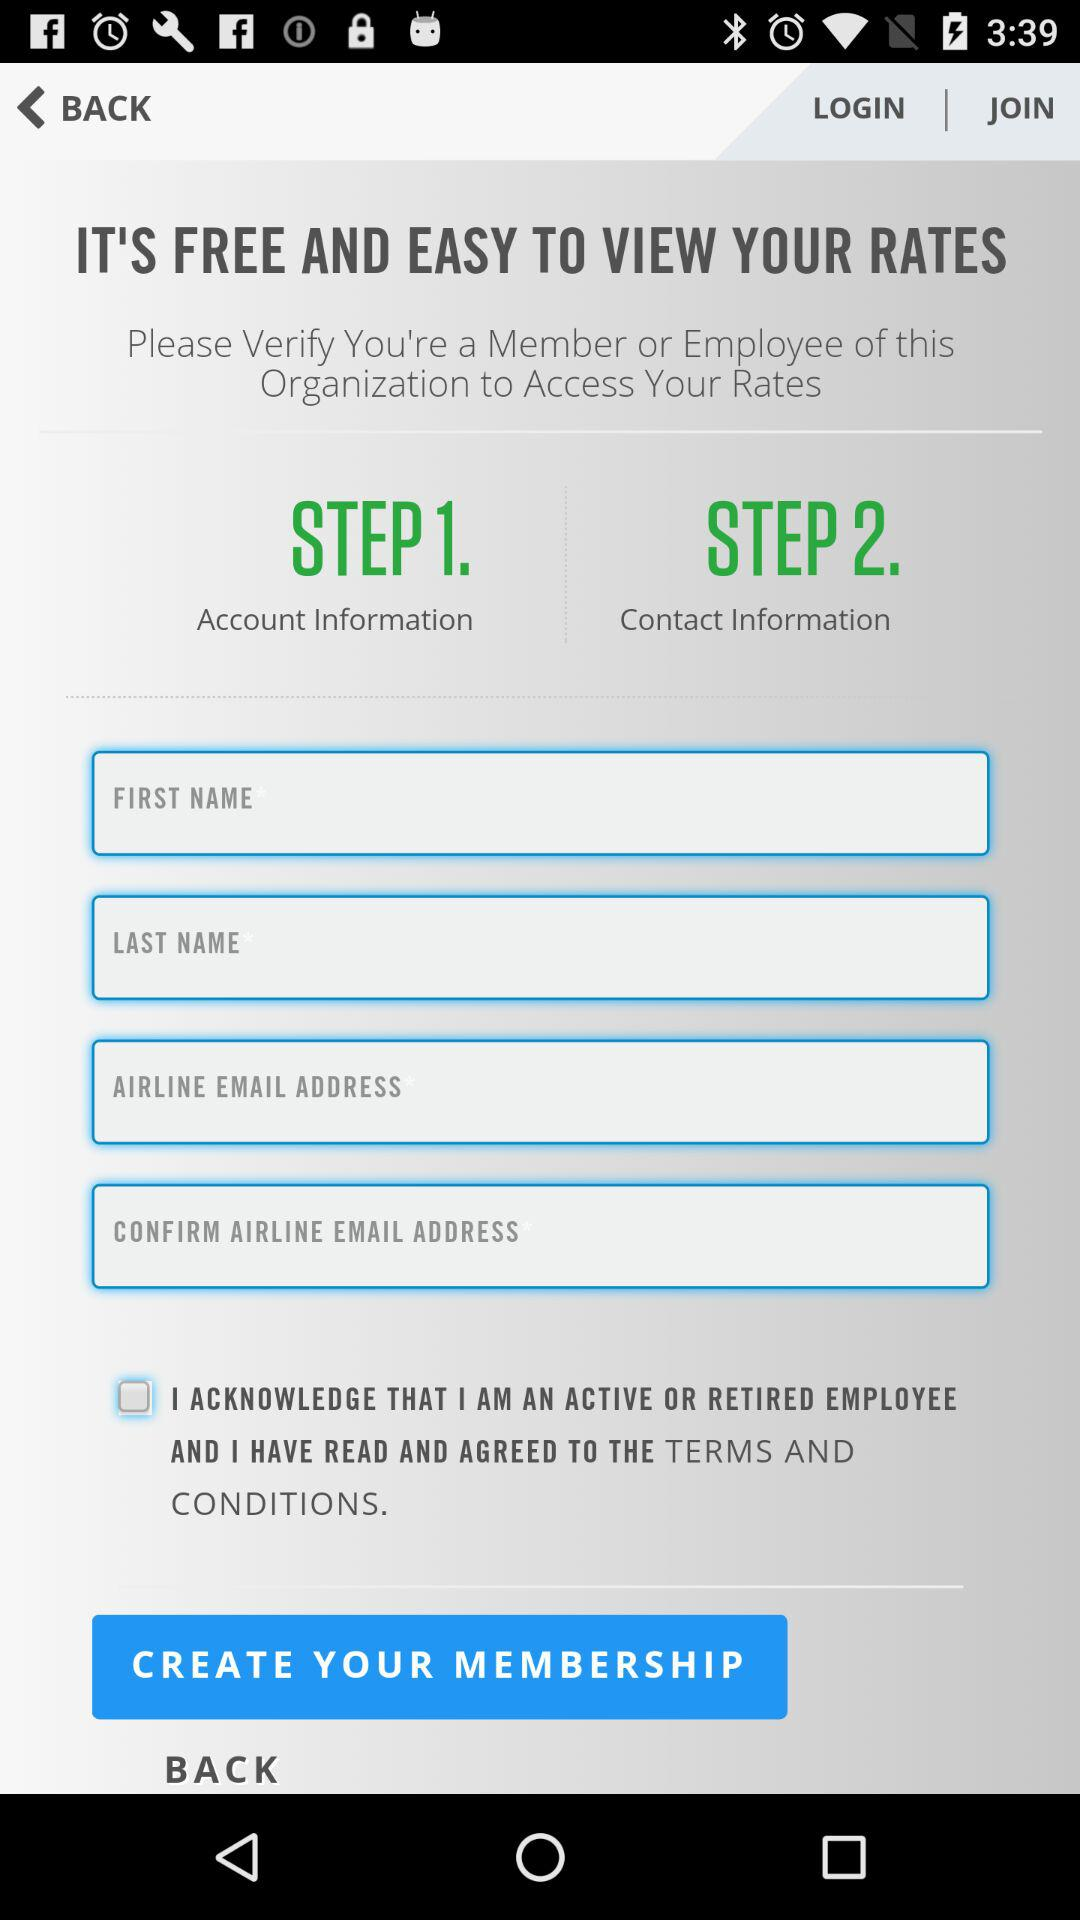What is the status of the option that includes agreement to the "TERMS AND CONDITIONS"? The status is "off". 